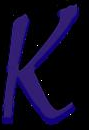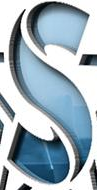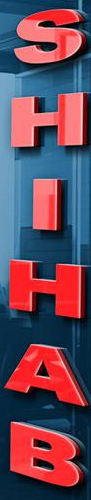What text is displayed in these images sequentially, separated by a semicolon? k; S; SHIHAB 